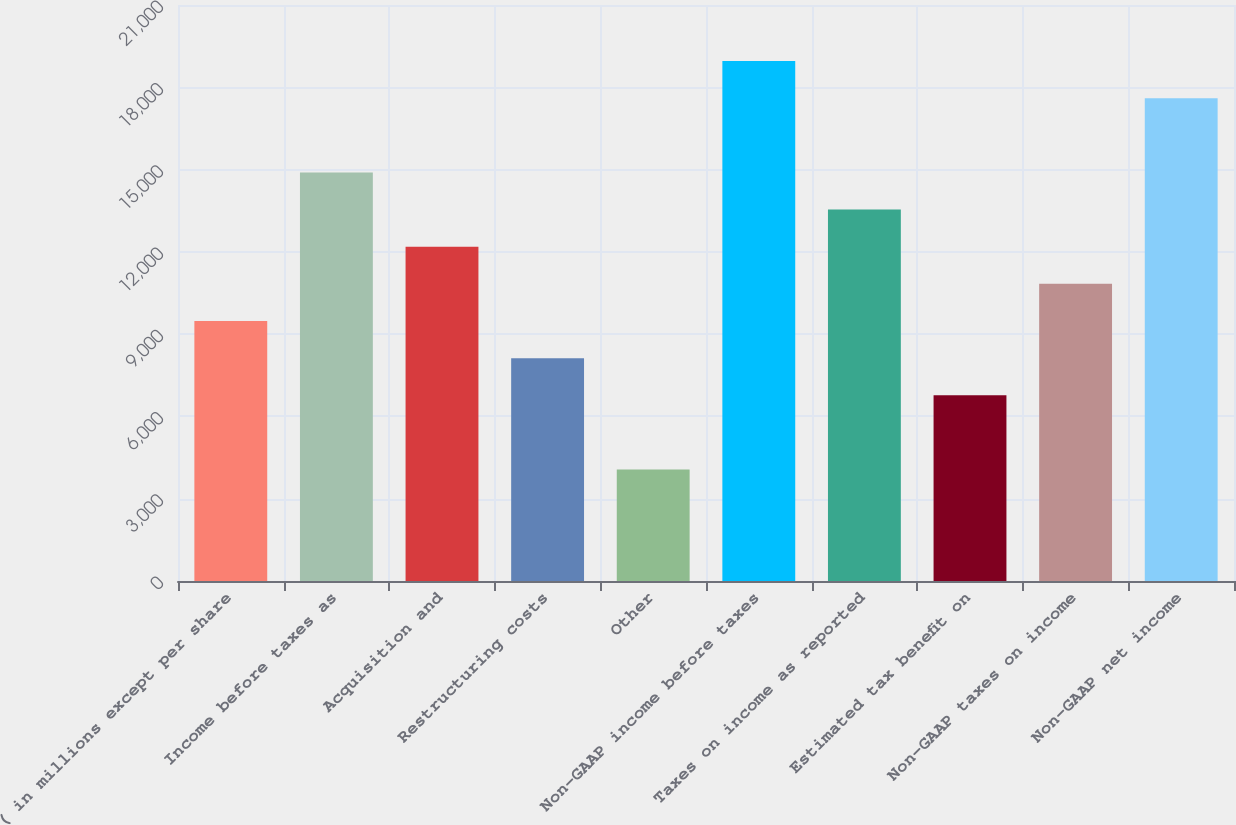Convert chart. <chart><loc_0><loc_0><loc_500><loc_500><bar_chart><fcel>( in millions except per share<fcel>Income before taxes as<fcel>Acquisition and<fcel>Restructuring costs<fcel>Other<fcel>Non-GAAP income before taxes<fcel>Taxes on income as reported<fcel>Estimated tax benefit on<fcel>Non-GAAP taxes on income<fcel>Non-GAAP net income<nl><fcel>9479.64<fcel>14896.1<fcel>12187.9<fcel>8125.53<fcel>4063.2<fcel>18958.4<fcel>13542<fcel>6771.42<fcel>10833.8<fcel>17604.3<nl></chart> 